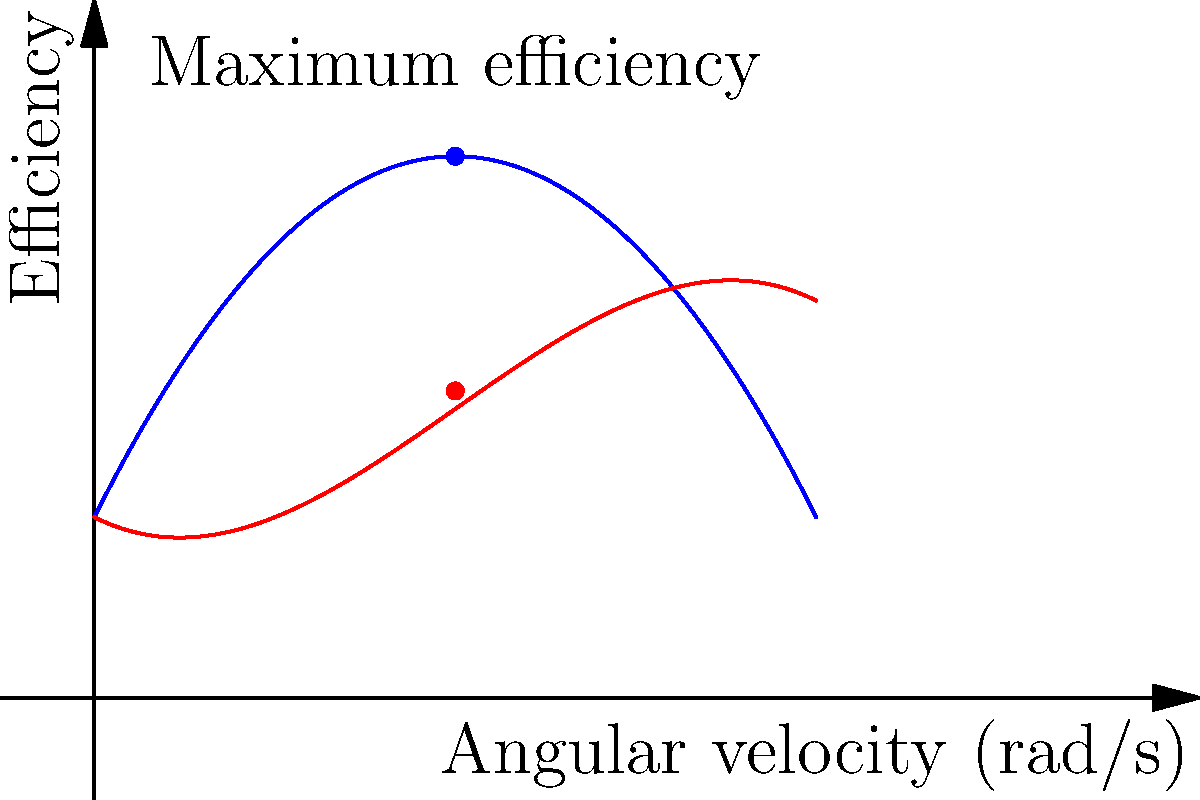In a patent application for a novel gear system, you've come across an efficiency curve for two different gears, A and B, as shown in the graph. The efficiency (η) of Gear A is given by the function η(ω) = -0.5ω² + 2ω + 1, where ω is the angular velocity in rad/s. What is the maximum efficiency of Gear A, and at what angular velocity does it occur? To find the maximum efficiency of Gear A and the corresponding angular velocity, we need to follow these steps:

1) The efficiency function for Gear A is given by:
   η(ω) = -0.5ω² + 2ω + 1

2) To find the maximum, we need to find where the derivative of this function equals zero:
   η'(ω) = -ω + 2

3) Set the derivative to zero and solve for ω:
   -ω + 2 = 0
   -ω = -2
   ω = 2 rad/s

4) To confirm this is a maximum (not a minimum), we can check the second derivative:
   η''(ω) = -1 < 0, confirming it's a maximum

5) Now, let's calculate the efficiency at ω = 2 rad/s:
   η(2) = -0.5(2)² + 2(2) + 1
        = -0.5(4) + 4 + 1
        = -2 + 4 + 1
        = 3

Therefore, the maximum efficiency of Gear A is 3 (or 300% if expressed as a percentage), occurring at an angular velocity of 2 rad/s.
Answer: Maximum efficiency: 3 (300%), at ω = 2 rad/s 